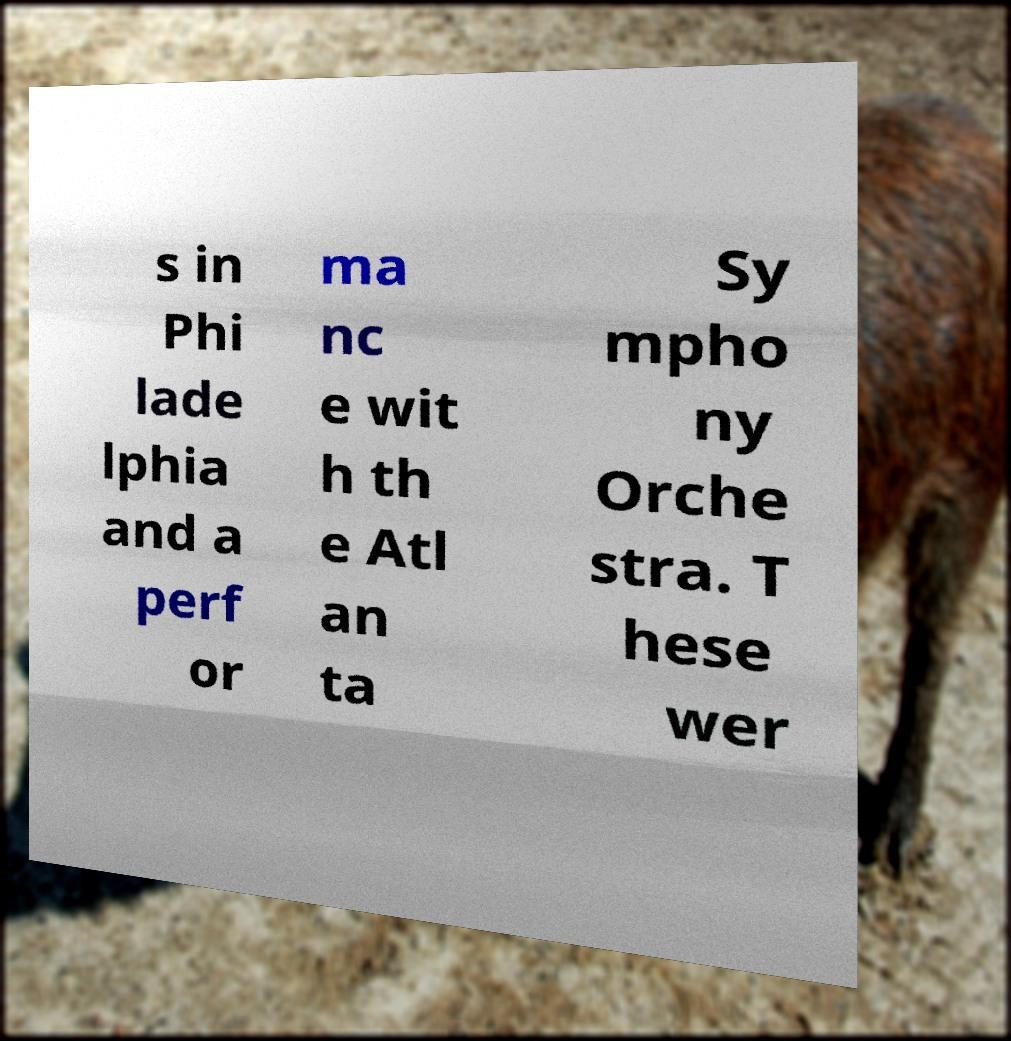What messages or text are displayed in this image? I need them in a readable, typed format. s in Phi lade lphia and a perf or ma nc e wit h th e Atl an ta Sy mpho ny Orche stra. T hese wer 